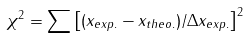Convert formula to latex. <formula><loc_0><loc_0><loc_500><loc_500>\chi ^ { 2 } = \sum \left [ ( x _ { e x p . } - x _ { t h e o . } ) / \Delta x _ { e x p . } \right ] ^ { 2 }</formula> 